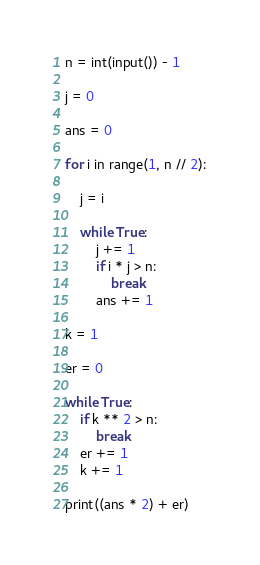<code> <loc_0><loc_0><loc_500><loc_500><_Python_>n = int(input()) - 1

j = 0

ans = 0

for i in range(1, n // 2):
    
    j = i
    
    while True:
        j += 1
        if i * j > n:
            break
        ans += 1

k = 1

er = 0

while True:
    if k ** 2 > n:
        break
    er += 1
    k += 1

print((ans * 2) + er)</code> 